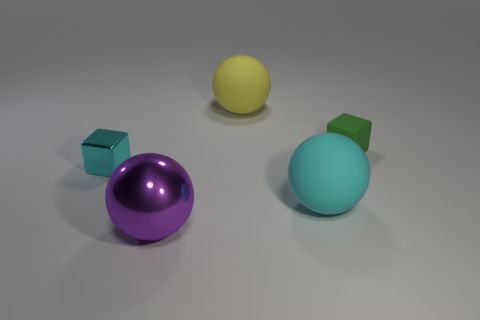What colors are the objects in the image? There are four objects in the image featuring distinct colors: a purple sphere, a yellow sphere, a turquoise sphere, and a green cube. 